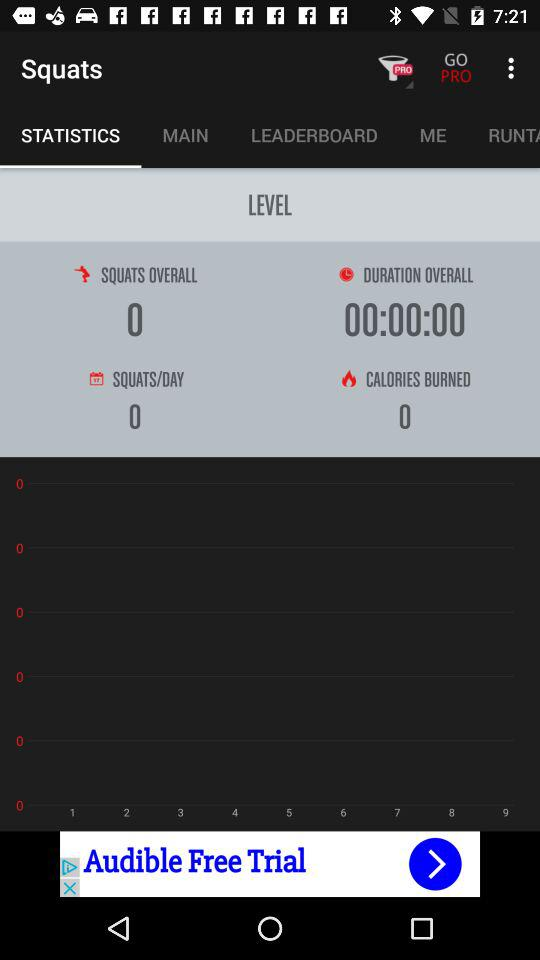Which tab is selected? The selected tab is "STATISTICS". 